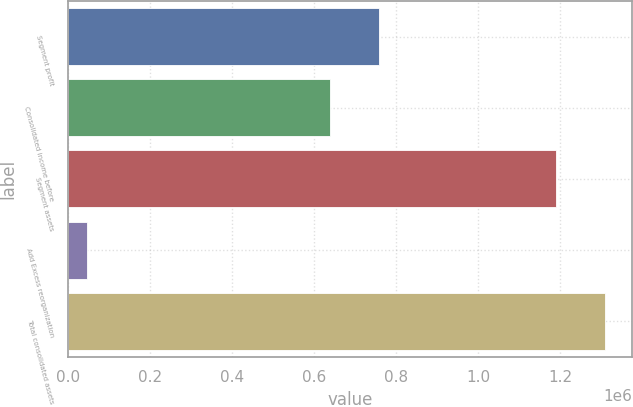<chart> <loc_0><loc_0><loc_500><loc_500><bar_chart><fcel>Segment profit<fcel>Consolidated income before<fcel>Segment assets<fcel>Add Excess reorganization<fcel>Total consolidated assets<nl><fcel>758544<fcel>638418<fcel>1.18845e+06<fcel>47959<fcel>1.30858e+06<nl></chart> 